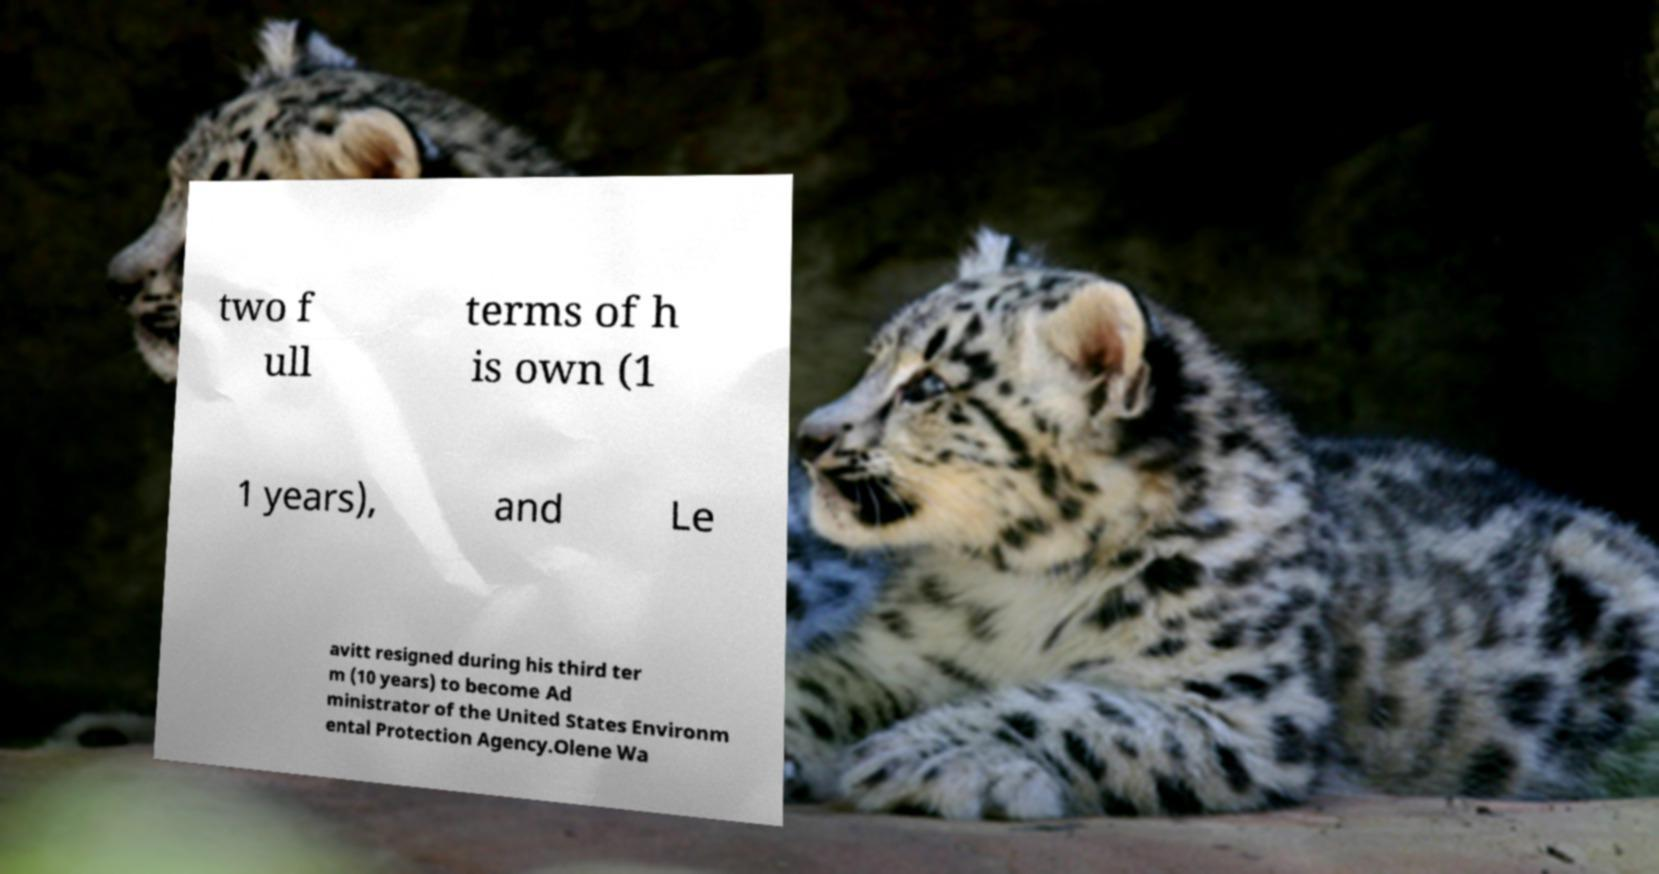For documentation purposes, I need the text within this image transcribed. Could you provide that? two f ull terms of h is own (1 1 years), and Le avitt resigned during his third ter m (10 years) to become Ad ministrator of the United States Environm ental Protection Agency.Olene Wa 